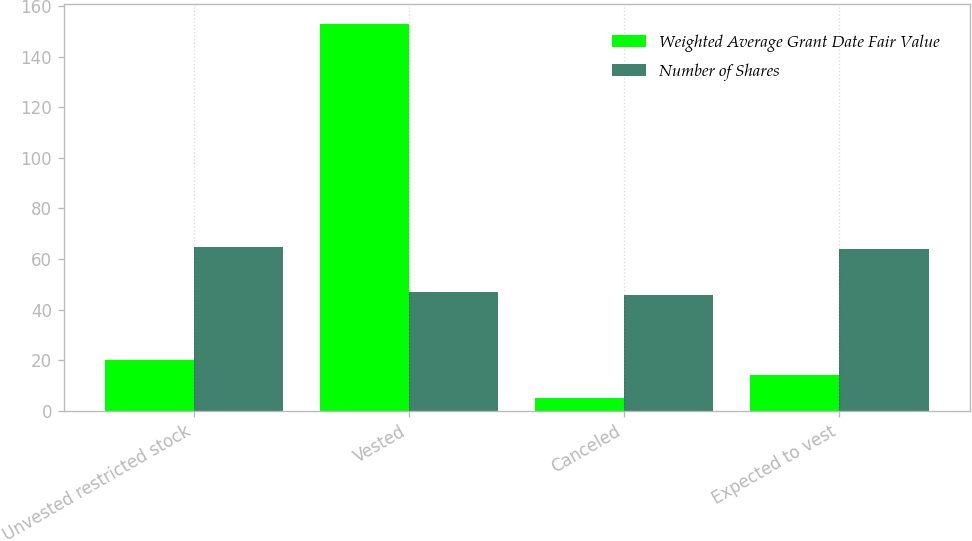<chart> <loc_0><loc_0><loc_500><loc_500><stacked_bar_chart><ecel><fcel>Unvested restricted stock<fcel>Vested<fcel>Canceled<fcel>Expected to vest<nl><fcel>Weighted Average Grant Date Fair Value<fcel>20<fcel>153<fcel>5<fcel>14<nl><fcel>Number of Shares<fcel>64.81<fcel>46.86<fcel>45.86<fcel>64<nl></chart> 